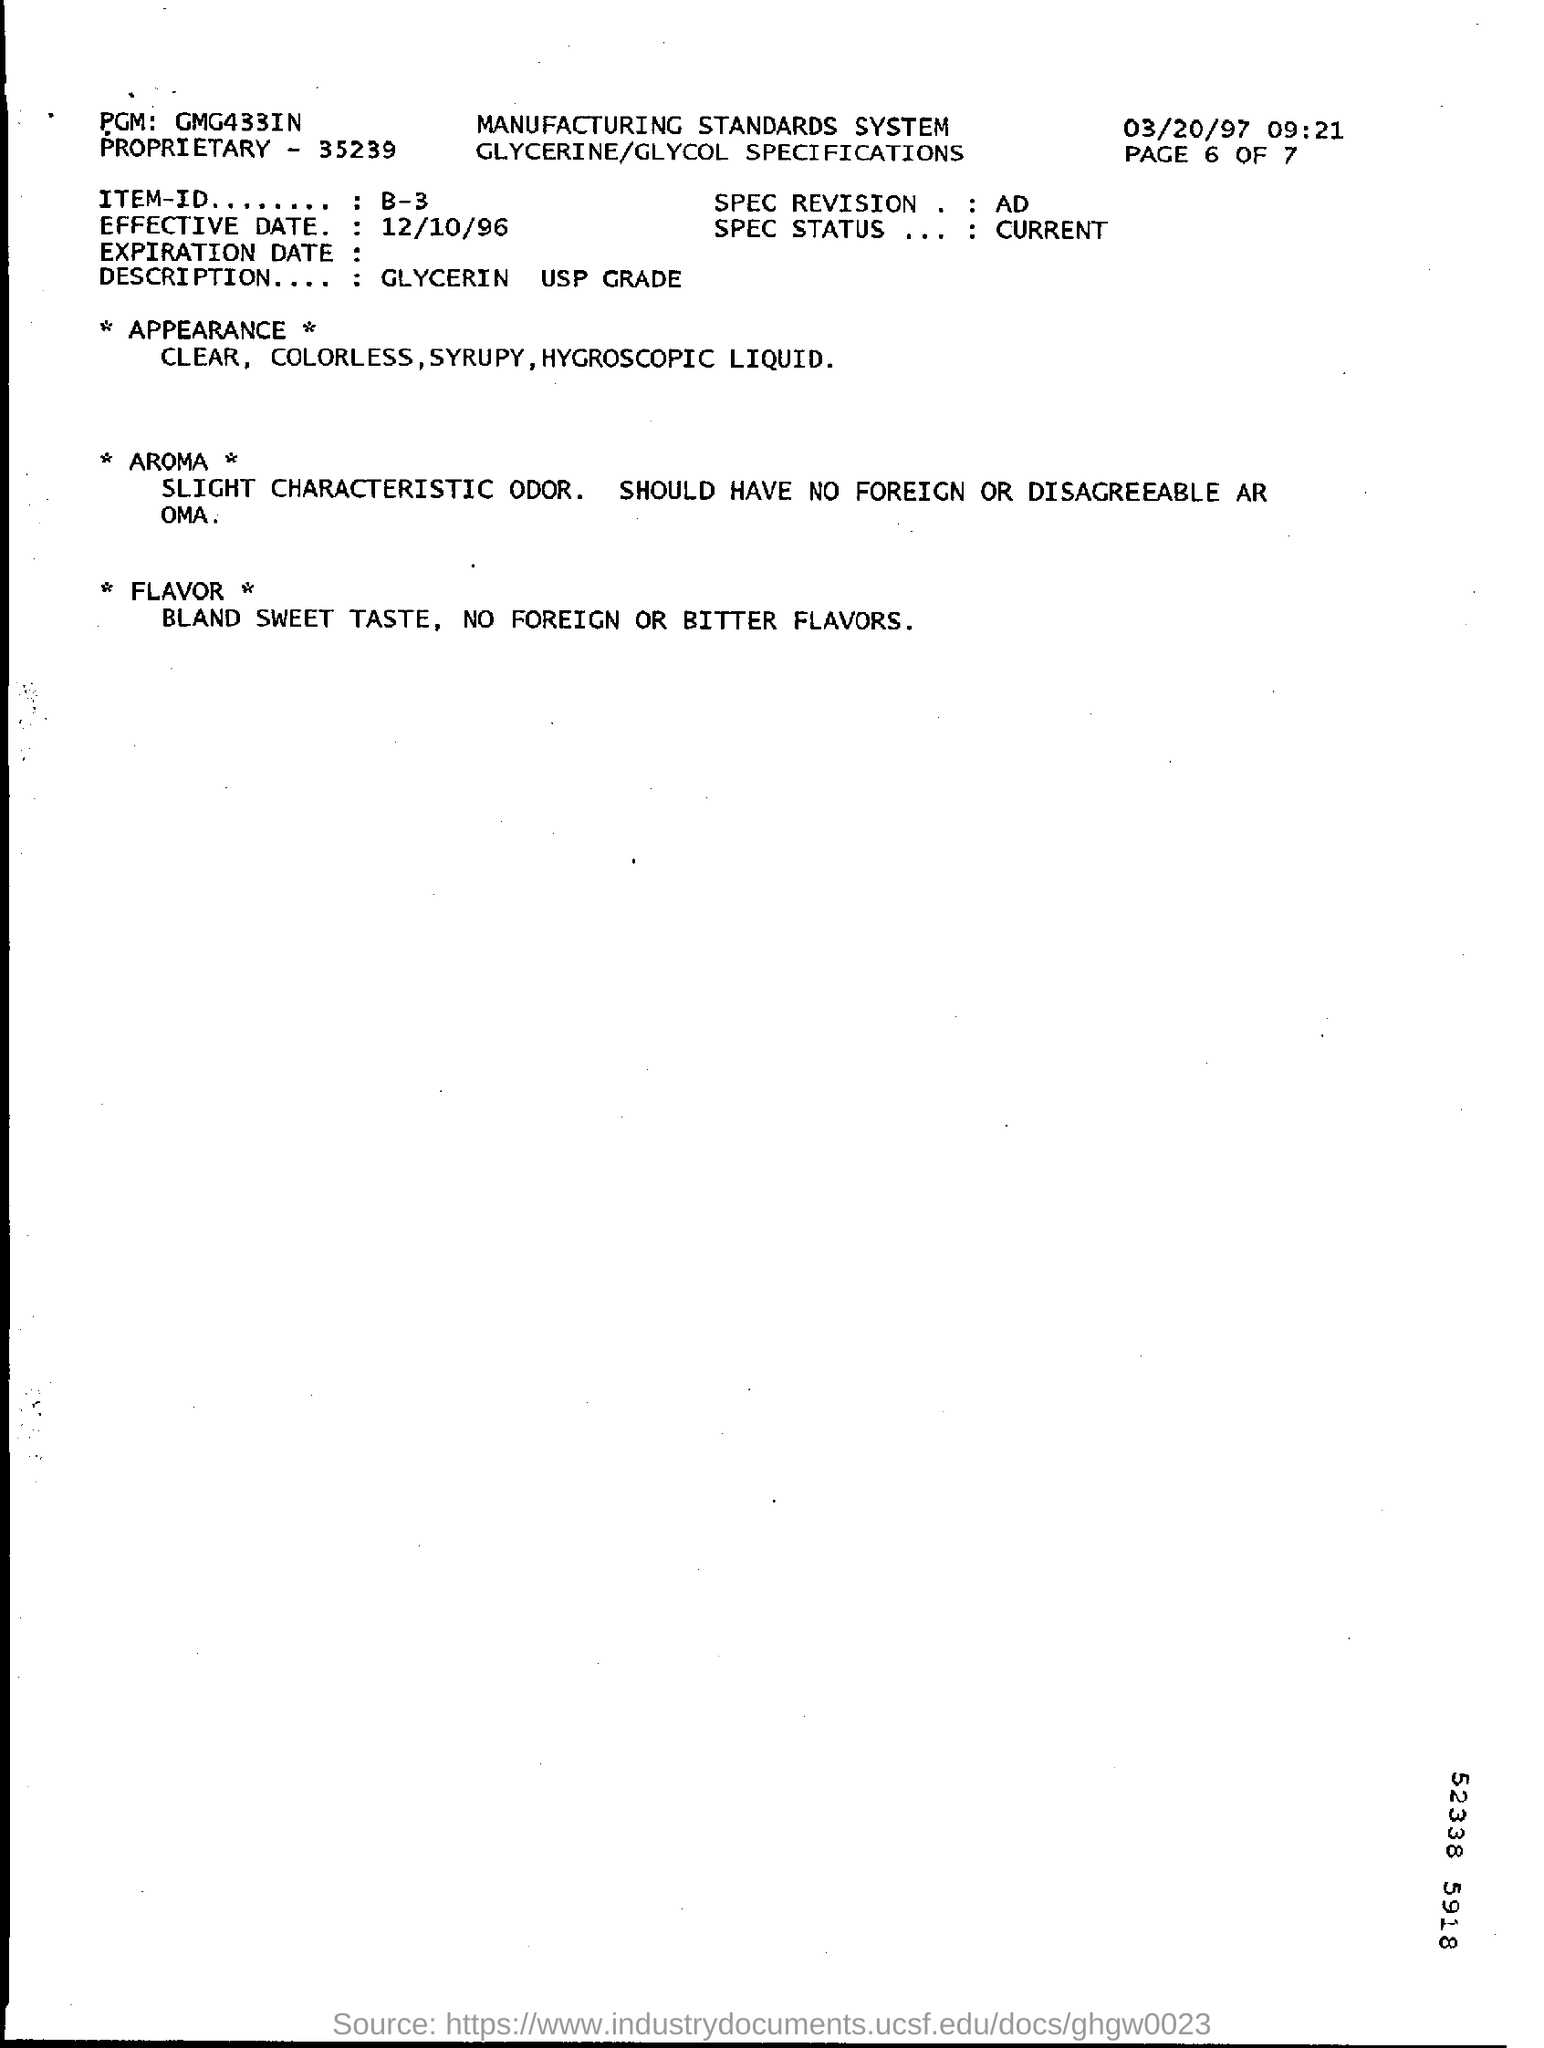What is the date mentioned in the top right corner of the document ?
Offer a very short reply. 03/20/97. What is written in the Top left of the document ?
Provide a succinct answer. PGM: GMG433IN. What is the Effective Date  ?
Your answer should be compact. 12/10/96. What is written in the Description Field ?
Ensure brevity in your answer.  GLYCERIN USP GRADE. What is mentioned in the Item-Id Field ?
Make the answer very short. B-3. 